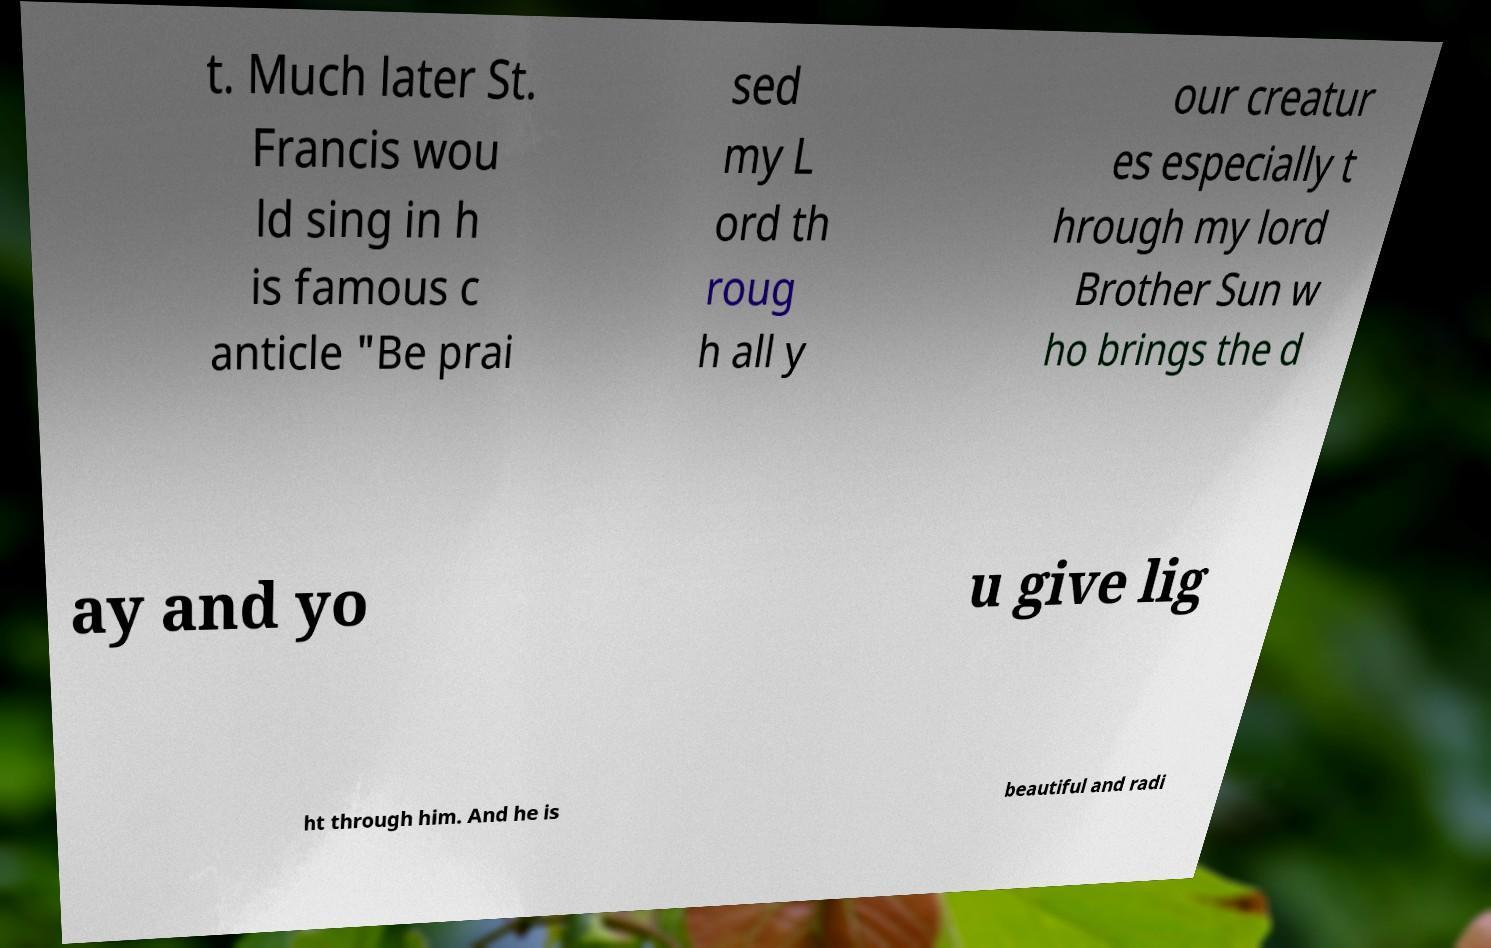Can you read and provide the text displayed in the image?This photo seems to have some interesting text. Can you extract and type it out for me? t. Much later St. Francis wou ld sing in h is famous c anticle "Be prai sed my L ord th roug h all y our creatur es especially t hrough my lord Brother Sun w ho brings the d ay and yo u give lig ht through him. And he is beautiful and radi 